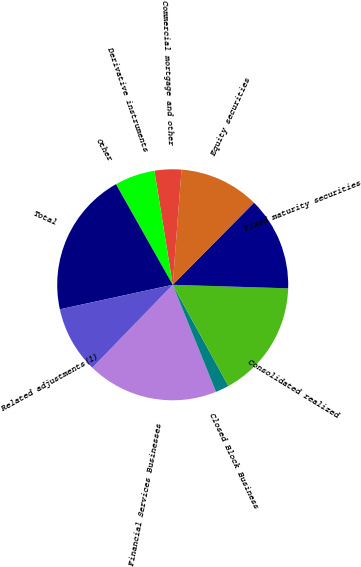Convert chart. <chart><loc_0><loc_0><loc_500><loc_500><pie_chart><fcel>Financial Services Businesses<fcel>Closed Block Business<fcel>Consolidated realized<fcel>Fixed maturity securities<fcel>Equity securities<fcel>Commercial mortgage and other<fcel>Derivative instruments<fcel>Other<fcel>Total<fcel>Related adjustments(1)<nl><fcel>18.37%<fcel>1.89%<fcel>16.51%<fcel>13.07%<fcel>11.2%<fcel>3.75%<fcel>5.62%<fcel>0.03%<fcel>20.23%<fcel>9.34%<nl></chart> 